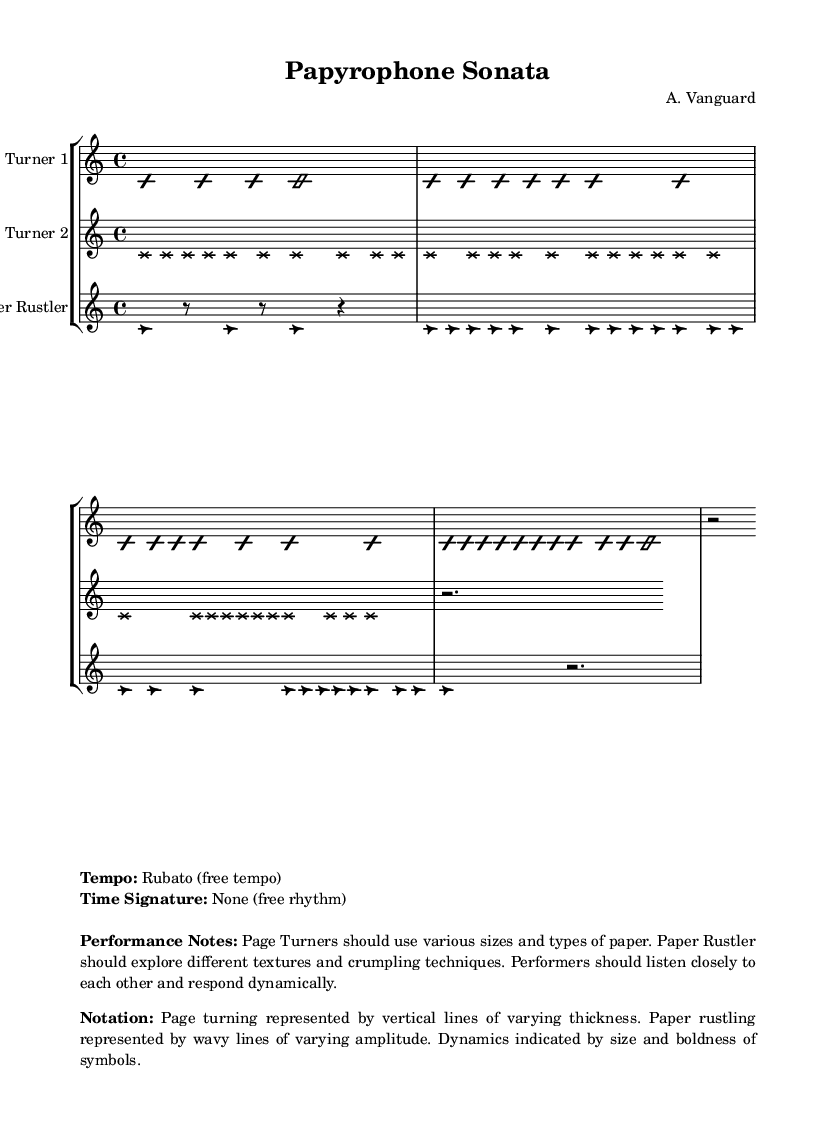What is the tempo of the composition? The tempo is indicated as "Rubato," which means free tempo, allowing performers to interpret the speed and rhythm flexibly.
Answer: Rubato What is the time signature used in this composition? The time signature is noted as "None," indicating that the piece does not adhere to a traditional time signature, allowing for free rhythm throughout.
Answer: None How many instruments are scored in this sheet music? The score consists of three distinct instruments, which are called "Page Turner 1," "Page Turner 2," and "Paper Rustler." This indicates that the composition features a performance of unique sound sources, creating avant-garde textures.
Answer: Three What is the primary technique used by the "Paper Rustler"? The "Paper Rustler" is instructed to explore "different textures and crumpling techniques," which suggests a focus on manipulating paper to produce varying sounds.
Answer: Crumpling Which musical notation represents page turning? Page turning is represented by vertical lines of varying thickness, allowing performers to interpret and produce the sound of turning pages visually through their notation.
Answer: Vertical lines What should the performers do in response to each other during the performance? The performers are instructed to "listen closely to each other and respond dynamically," emphasizing the importance of interaction and communication in the performance process.
Answer: Respond dynamically How are dynamics indicated in this score? Dynamics are indicated by the size and boldness of symbols, which provide visual cues on how loudly or softly to perform certain sections.
Answer: Size and boldness of symbols 